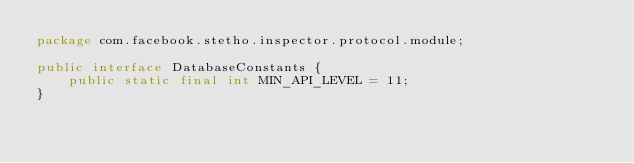Convert code to text. <code><loc_0><loc_0><loc_500><loc_500><_Java_>package com.facebook.stetho.inspector.protocol.module;

public interface DatabaseConstants {
    public static final int MIN_API_LEVEL = 11;
}
</code> 